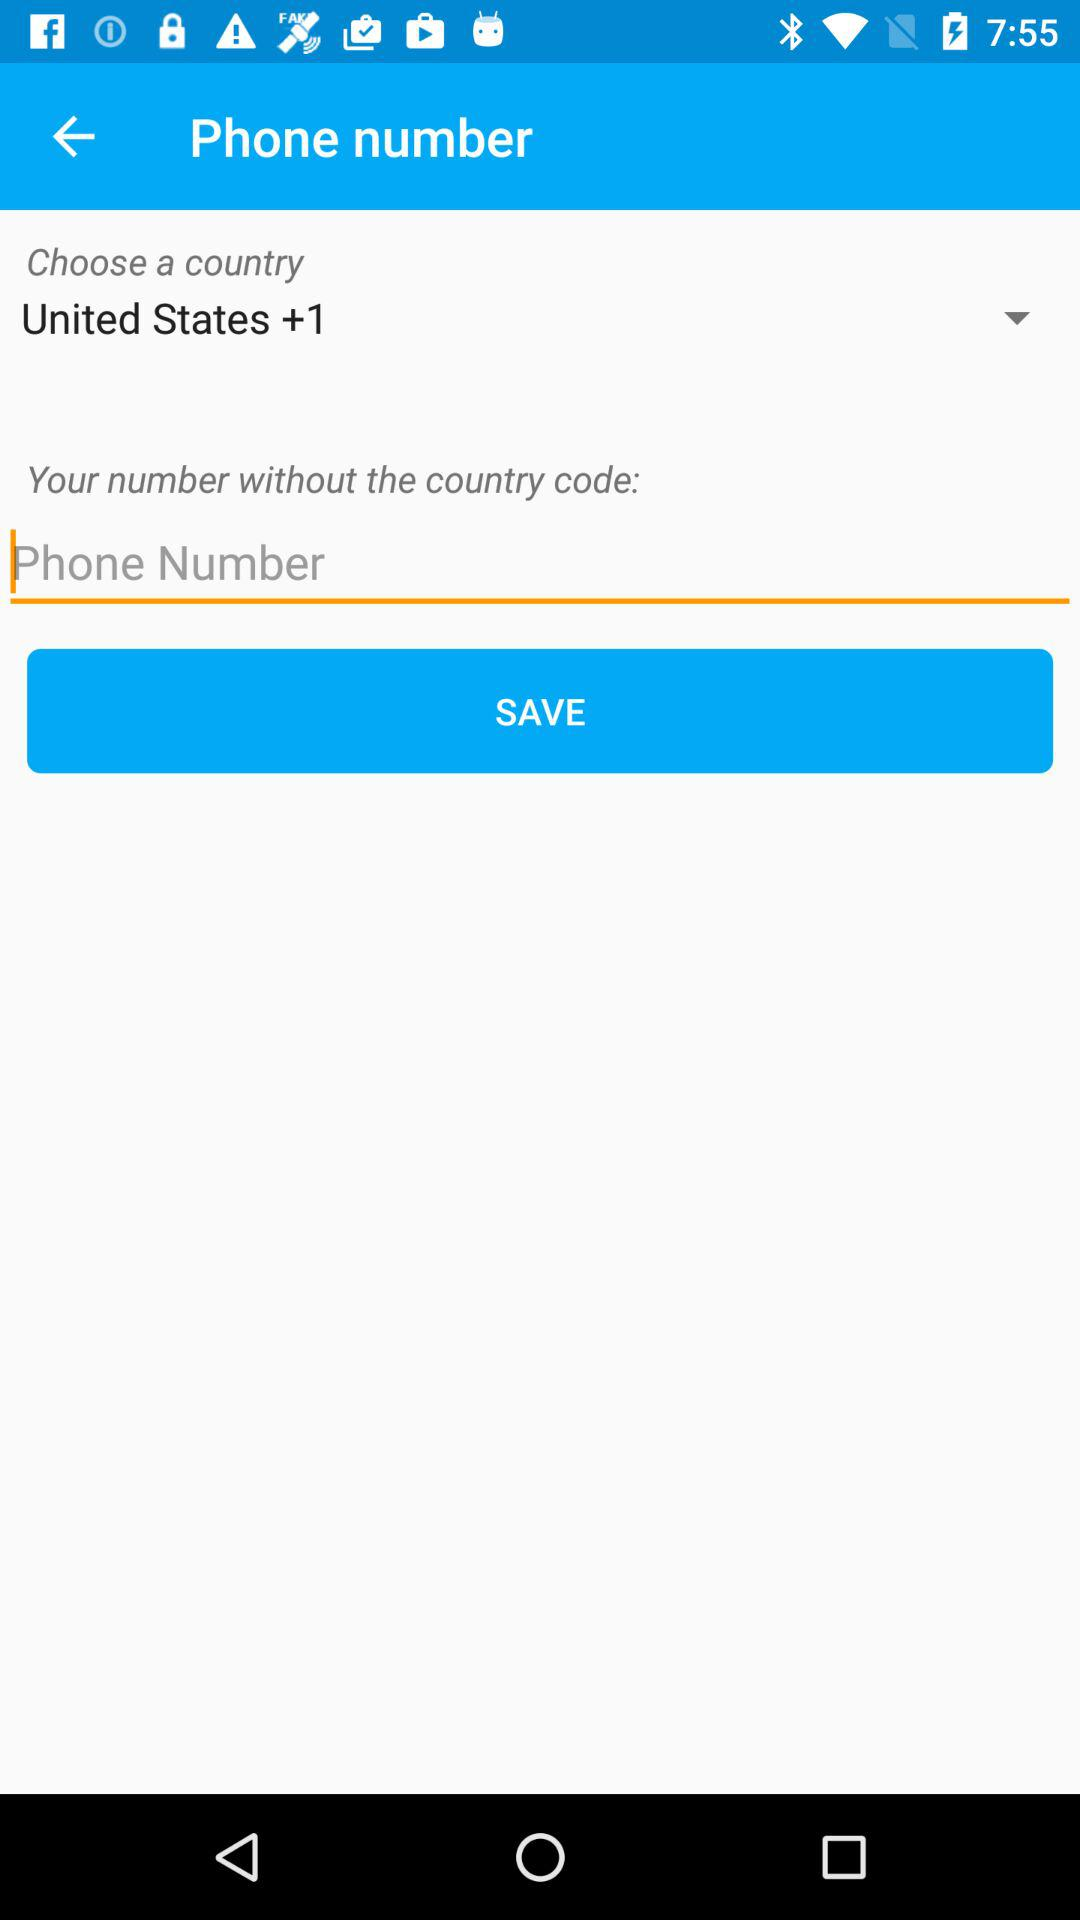What is the code of the United States? The code of the United States is +1. 